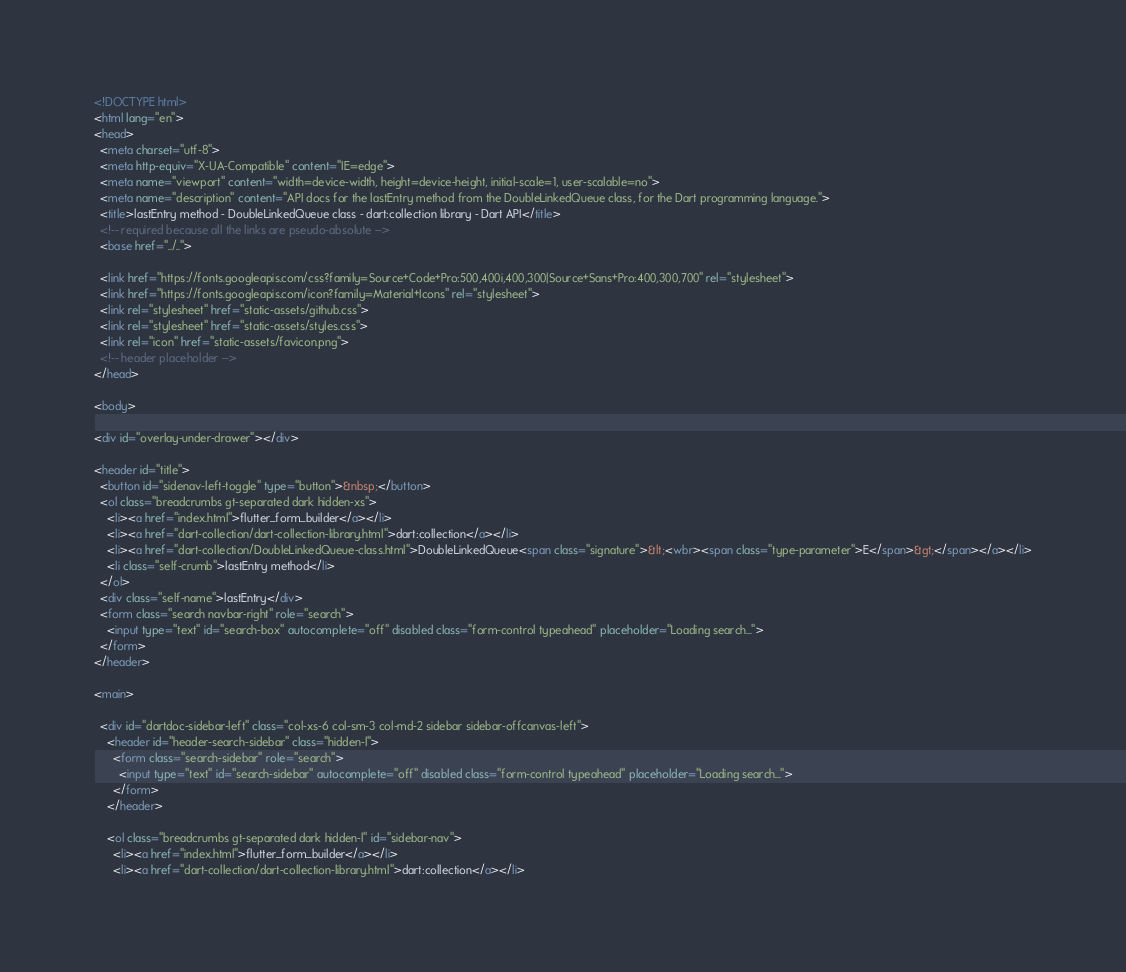<code> <loc_0><loc_0><loc_500><loc_500><_HTML_><!DOCTYPE html>
<html lang="en">
<head>
  <meta charset="utf-8">
  <meta http-equiv="X-UA-Compatible" content="IE=edge">
  <meta name="viewport" content="width=device-width, height=device-height, initial-scale=1, user-scalable=no">
  <meta name="description" content="API docs for the lastEntry method from the DoubleLinkedQueue class, for the Dart programming language.">
  <title>lastEntry method - DoubleLinkedQueue class - dart:collection library - Dart API</title>
  <!-- required because all the links are pseudo-absolute -->
  <base href="../..">

  <link href="https://fonts.googleapis.com/css?family=Source+Code+Pro:500,400i,400,300|Source+Sans+Pro:400,300,700" rel="stylesheet">
  <link href="https://fonts.googleapis.com/icon?family=Material+Icons" rel="stylesheet">
  <link rel="stylesheet" href="static-assets/github.css">
  <link rel="stylesheet" href="static-assets/styles.css">
  <link rel="icon" href="static-assets/favicon.png">
  <!-- header placeholder -->
</head>

<body>

<div id="overlay-under-drawer"></div>

<header id="title">
  <button id="sidenav-left-toggle" type="button">&nbsp;</button>
  <ol class="breadcrumbs gt-separated dark hidden-xs">
    <li><a href="index.html">flutter_form_builder</a></li>
    <li><a href="dart-collection/dart-collection-library.html">dart:collection</a></li>
    <li><a href="dart-collection/DoubleLinkedQueue-class.html">DoubleLinkedQueue<span class="signature">&lt;<wbr><span class="type-parameter">E</span>&gt;</span></a></li>
    <li class="self-crumb">lastEntry method</li>
  </ol>
  <div class="self-name">lastEntry</div>
  <form class="search navbar-right" role="search">
    <input type="text" id="search-box" autocomplete="off" disabled class="form-control typeahead" placeholder="Loading search...">
  </form>
</header>

<main>

  <div id="dartdoc-sidebar-left" class="col-xs-6 col-sm-3 col-md-2 sidebar sidebar-offcanvas-left">
    <header id="header-search-sidebar" class="hidden-l">
      <form class="search-sidebar" role="search">
        <input type="text" id="search-sidebar" autocomplete="off" disabled class="form-control typeahead" placeholder="Loading search...">
      </form>
    </header>
    
    <ol class="breadcrumbs gt-separated dark hidden-l" id="sidebar-nav">
      <li><a href="index.html">flutter_form_builder</a></li>
      <li><a href="dart-collection/dart-collection-library.html">dart:collection</a></li></code> 